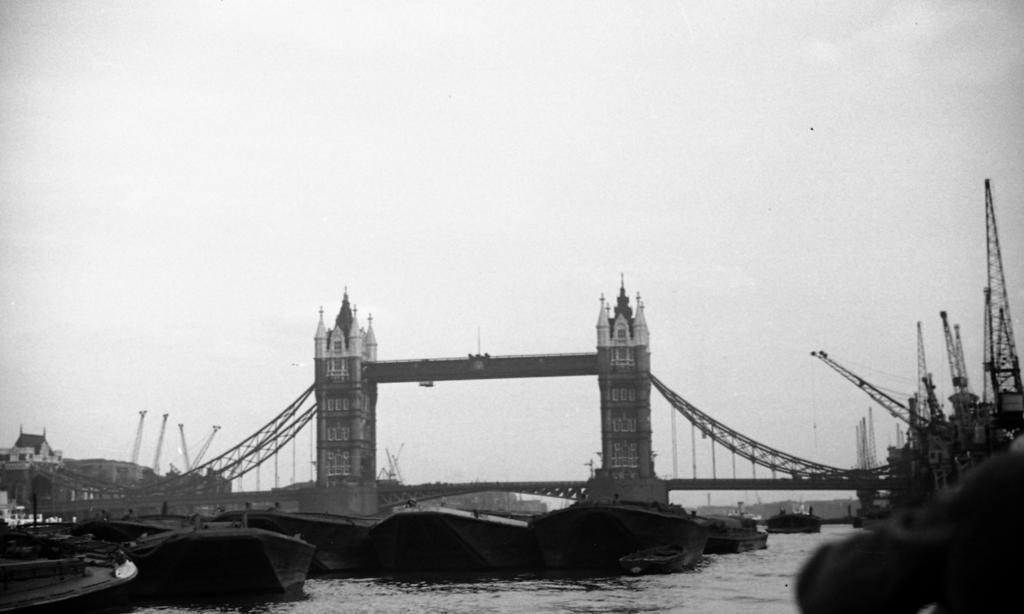Describe this image in one or two sentences. In this picture we can observe a bridge over the river. There is a fleet on the water. On the right side we can observe some mobile cranes. In the background there is a sky. 